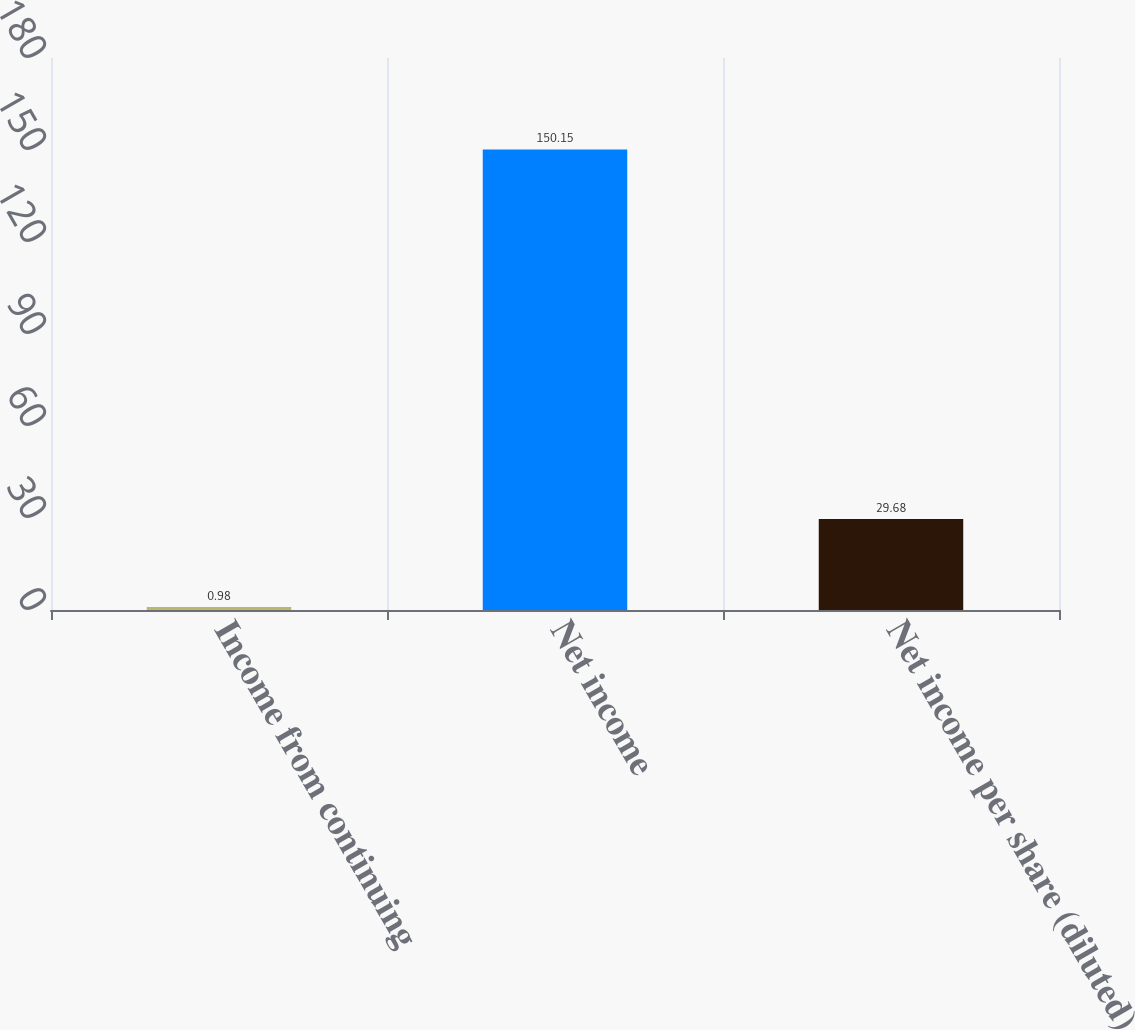Convert chart to OTSL. <chart><loc_0><loc_0><loc_500><loc_500><bar_chart><fcel>Income from continuing<fcel>Net income<fcel>Net income per share (diluted)<nl><fcel>0.98<fcel>150.15<fcel>29.68<nl></chart> 